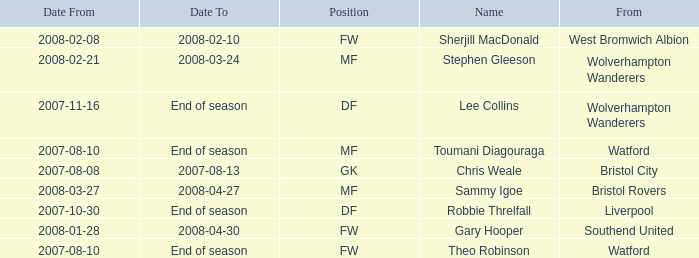Where was the player from who had the position of DF, who started 2007-10-30? Liverpool. 